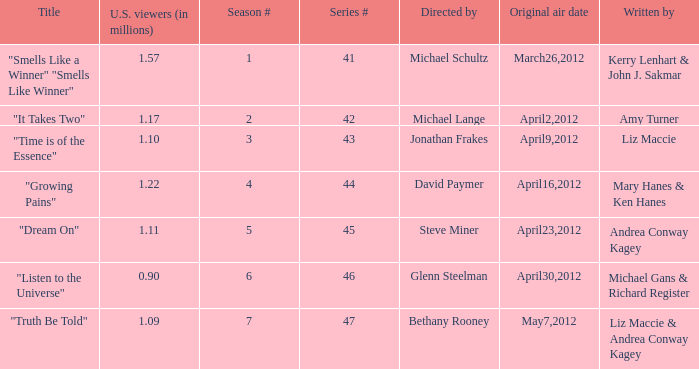What is the title of the episode/s written by Michael Gans & Richard Register? "Listen to the Universe". 